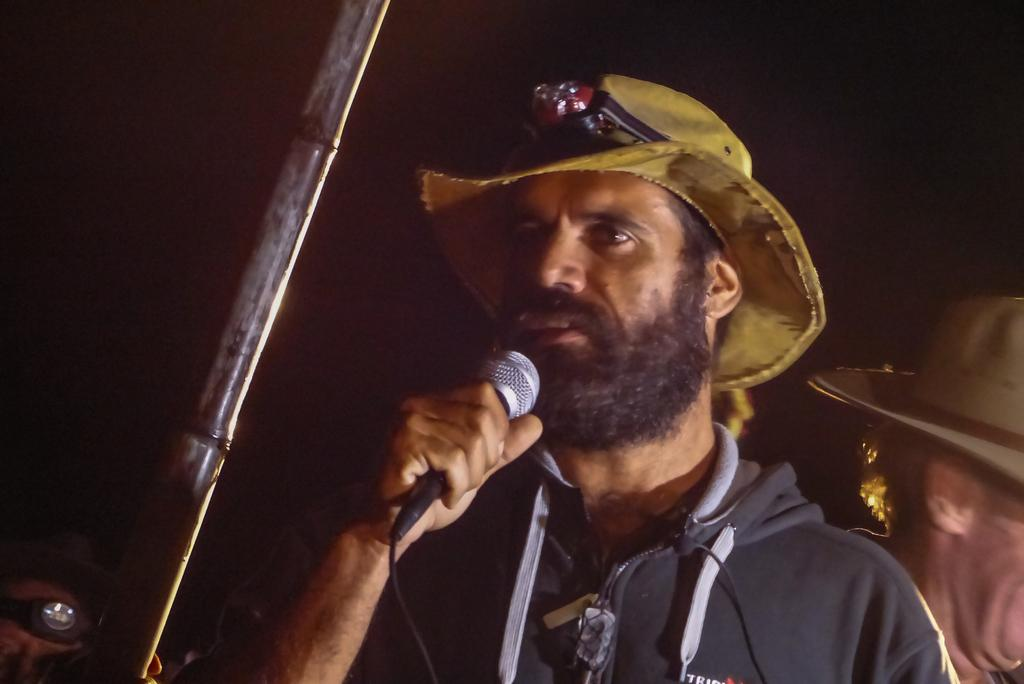What is the color of the man's hat in the image? The man is wearing a yellow hat in the image. What is the man holding in his hand? The man is holding a microphone in his hand. What is the man doing in the image? The man is talking. How many other men are wearing hats in the image? There are two other men wearing hats in the image. What type of crack can be heard in the background of the image? There is no crack sound present in the image; it is a man talking with a microphone. 